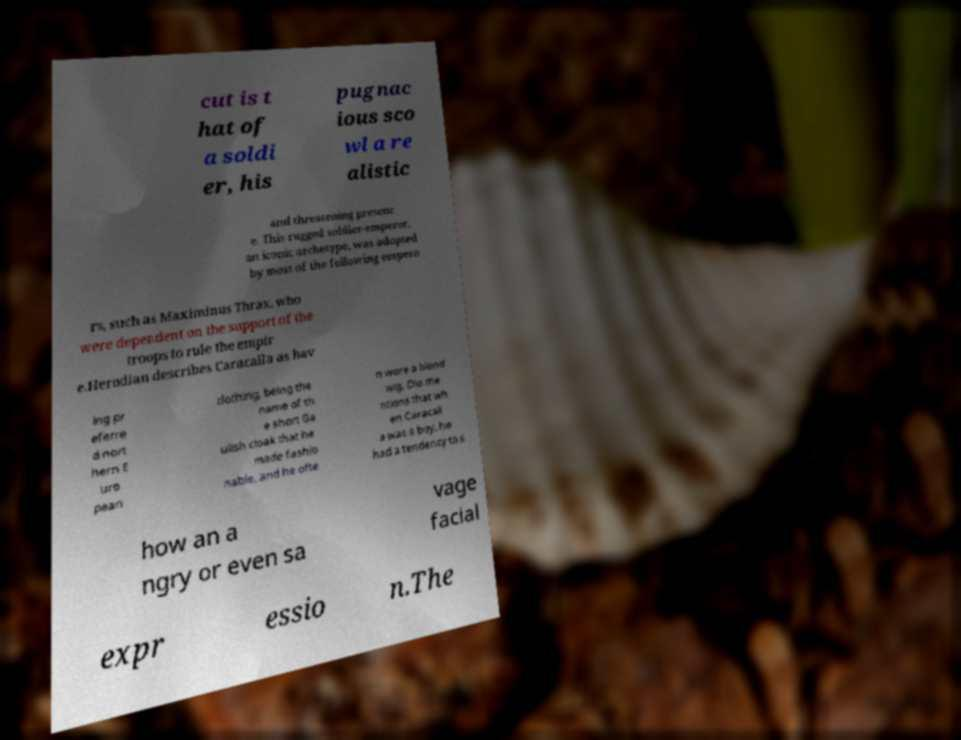I need the written content from this picture converted into text. Can you do that? cut is t hat of a soldi er, his pugnac ious sco wl a re alistic and threatening presenc e. This rugged soldier-emperor, an iconic archetype, was adopted by most of the following empero rs, such as Maximinus Thrax, who were dependent on the support of the troops to rule the empir e.Herodian describes Caracalla as hav ing pr eferre d nort hern E uro pean clothing, being the name of th e short Ga ulish cloak that he made fashio nable, and he ofte n wore a blond wig. Dio me ntions that wh en Caracall a was a boy, he had a tendency to s how an a ngry or even sa vage facial expr essio n.The 